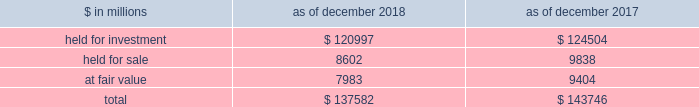The goldman sachs group , inc .
And subsidiaries notes to consolidated financial statements lending commitments the firm 2019s lending commitments are agreements to lend with fixed termination dates and depend on the satisfaction of all contractual conditions to borrowing .
These commitments are presented net of amounts syndicated to third parties .
The total commitment amount does not necessarily reflect actual future cash flows because the firm may syndicate all or substantial additional portions of these commitments .
In addition , commitments can expire unused or be reduced or cancelled at the counterparty 2019s request .
The table below presents information about lending commitments. .
In the table above : 2030 held for investment lending commitments are accounted for on an accrual basis .
See note 9 for further information about such commitments .
2030 held for sale lending commitments are accounted for at the lower of cost or fair value .
2030 gains or losses related to lending commitments at fair value , if any , are generally recorded , net of any fees in other principal transactions .
2030 substantially all lending commitments relates to the firm 2019s investing & lending segment .
Commercial lending .
The firm 2019s commercial lending commitments were primarily extended to investment-grade corporate borrowers .
Such commitments included $ 93.99 billion as of december 2018 and $ 85.98 billion as of december 2017 , related to relationship lending activities ( principally used for operating and general corporate purposes ) and $ 27.92 billion as of december 2018 and $ 42.41 billion as of december 2017 , related to other investment banking activities ( generally extended for contingent acquisition financing and are often intended to be short-term in nature , as borrowers often seek to replace them with other funding sources ) .
The firm also extends lending commitments in connection with other types of corporate lending , as well as commercial real estate financing .
See note 9 for further information about funded loans .
Sumitomo mitsui financial group , inc .
( smfg ) provides the firm with credit loss protection on certain approved loan commitments ( primarily investment-grade commercial lending commitments ) .
The notional amount of such loan commitments was $ 15.52 billion as of december 2018 and $ 25.70 billion as of december 2017 .
The credit loss protection on loan commitments provided by smfg is generally limited to 95% ( 95 % ) of the first loss the firm realizes on such commitments , up to a maximum of approximately $ 950 million .
In addition , subject to the satisfaction of certain conditions , upon the firm 2019s request , smfg will provide protection for 70% ( 70 % ) of additional losses on such commitments , up to a maximum of $ 1.0 billion , of which $ 550 million of protection had been provided as of both december 2018 and december 2017 .
The firm also uses other financial instruments to mitigate credit risks related to certain commitments not covered by smfg .
These instruments primarily include credit default swaps that reference the same or similar underlying instrument or entity , or credit default swaps that reference a market index .
Warehouse financing .
The firm provides financing to clients who warehouse financial assets .
These arrangements are secured by the warehoused assets , primarily consisting of consumer and corporate loans .
Contingent and forward starting collateralized agreements / forward starting collateralized financings forward starting collateralized agreements includes resale and securities borrowing agreements , and forward starting collateralized financings includes repurchase and secured lending agreements that settle at a future date , generally within three business days .
The firm also enters into commitments to provide contingent financing to its clients and counterparties through resale agreements .
The firm 2019s funding of these commitments depends on the satisfaction of all contractual conditions to the resale agreement and these commitments can expire unused .
Letters of credit the firm has commitments under letters of credit issued by various banks which the firm provides to counterparties in lieu of securities or cash to satisfy various collateral and margin deposit requirements .
Investment commitments investment commitments includes commitments to invest in private equity , real estate and other assets directly and through funds that the firm raises and manages .
Investment commitments included $ 2.42 billion as of december 2018 and $ 2.09 billion as of december 2017 , related to commitments to invest in funds managed by the firm .
If these commitments are called , they would be funded at market value on the date of investment .
Goldman sachs 2018 form 10-k 159 .
For the firm 2019s commercial lending commitments primarily extended to investment-grade corporate borrowers , what was the change in billions as of december 2018 and december 2017? 
Computations: (93.99 - 85.98)
Answer: 8.01. 